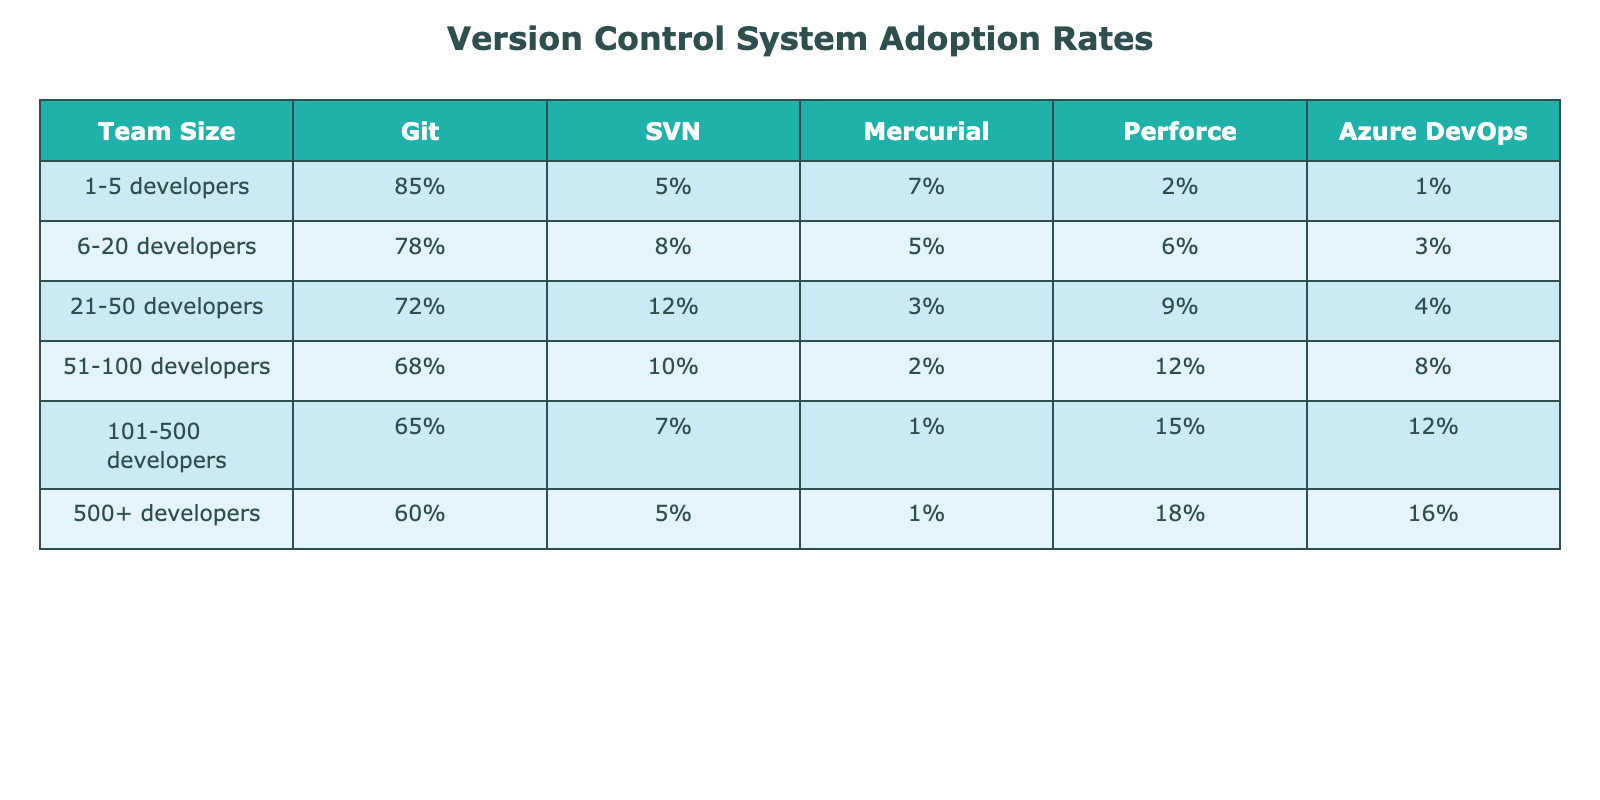What is the adoption rate of Git among teams of 1-5 developers? From the table, the adoption rate of Git in the category of 1-5 developers is clearly shown as 85%.
Answer: 85% Which version control system has the highest adoption rate among teams of 21-50 developers? According to the table, Git has the highest adoption rate at 72% in that team size category.
Answer: Git What percentage of 101-500 developers use Azure DevOps? The table shows that Azure DevOps is used by 12% of teams in the 101-500 developer category.
Answer: 12% Is Perforce used by more than 15% of teams in any size category? By reviewing the table, it is evident that Perforce is only used by a maximum of 18% of teams in the 500+ developers category, which is indeed greater than 15%.
Answer: Yes What is the difference in Git adoption rates between teams with 51-100 developers and those with 6-20 developers? The Git adoption rate for 51-100 developers is 68%, while for 6-20 developers, it's 78%. The difference is 78% - 68% = 10%.
Answer: 10% What is the average adoption rate of SVN across all team sizes? The SVN adoption rates are as follows: 5%, 8%, 12%, 10%, 7%, and 5%. Summing these gives 5 + 8 + 12 + 10 + 7 + 5 = 47%. Dividing by 6 (the number of categories) provides an average of 47% / 6 ≈ 7.83%.
Answer: Approximately 7.83% Among all team sizes, which version control system experiences the steepest decline in adoption from 1-5 developers to 500+ developers? Reviewing the data for each system shows that Git declines from 85% to 60% (25%), and Perforce declines from 2% to 18% (16%). Comparing all, Git's decline is the steepest at 25%.
Answer: Git If you were to categorize Azure DevOps adoption into teams of smaller sizes (1-20 developers) versus larger sizes (21+ developers), what percentage would this represent? Azure DevOps is used by 85% of teams in the small size group (1-20 developers), while in the larger group (21+ developers), it has adoption rates of 4% and 12% respectively. Summing the smaller group's percentage results in 85% versus a larger group that totals to 16%.
Answer: 85% vs 16% What is the total percentage adoption of SVN among teams of 21-50 developers and 101-500 developers? For the 21-50 developer group, SVN has an adoption rate of 12%, and for the 101-500 group, it has a rate of 7%. Therefore, the total is 12% + 7% = 19%.
Answer: 19% Is the adoption rate of Mercurial across all developers generally decreasing? Across various team sizes, the rates are 7%, 5%, 3%, 2%, 1%, and 1%. Each subsequent category shows a decrease, confirming that the rate is indeed declining.
Answer: Yes 